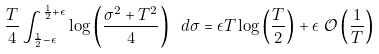<formula> <loc_0><loc_0><loc_500><loc_500>\frac { T } { 4 } \int _ { \frac { 1 } { 2 } - \epsilon } ^ { \frac { 1 } { 2 } + \epsilon } \log \left ( \frac { \sigma ^ { 2 } + T ^ { 2 } } { 4 } \right ) \ d \sigma & = \epsilon T \log \left ( \frac { T } { 2 } \right ) + \epsilon \ \mathcal { O } \left ( \frac { 1 } { T } \right )</formula> 